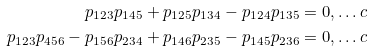<formula> <loc_0><loc_0><loc_500><loc_500>p _ { 1 2 3 } p _ { 1 4 5 } + p _ { 1 2 5 } p _ { 1 3 4 } - p _ { 1 2 4 } p _ { 1 3 5 } & = 0 , \dots c \\ p _ { 1 2 3 } p _ { 4 5 6 } - p _ { 1 5 6 } p _ { 2 3 4 } + p _ { 1 4 6 } p _ { 2 3 5 } - p _ { 1 4 5 } p _ { 2 3 6 } & = 0 , \dots c</formula> 